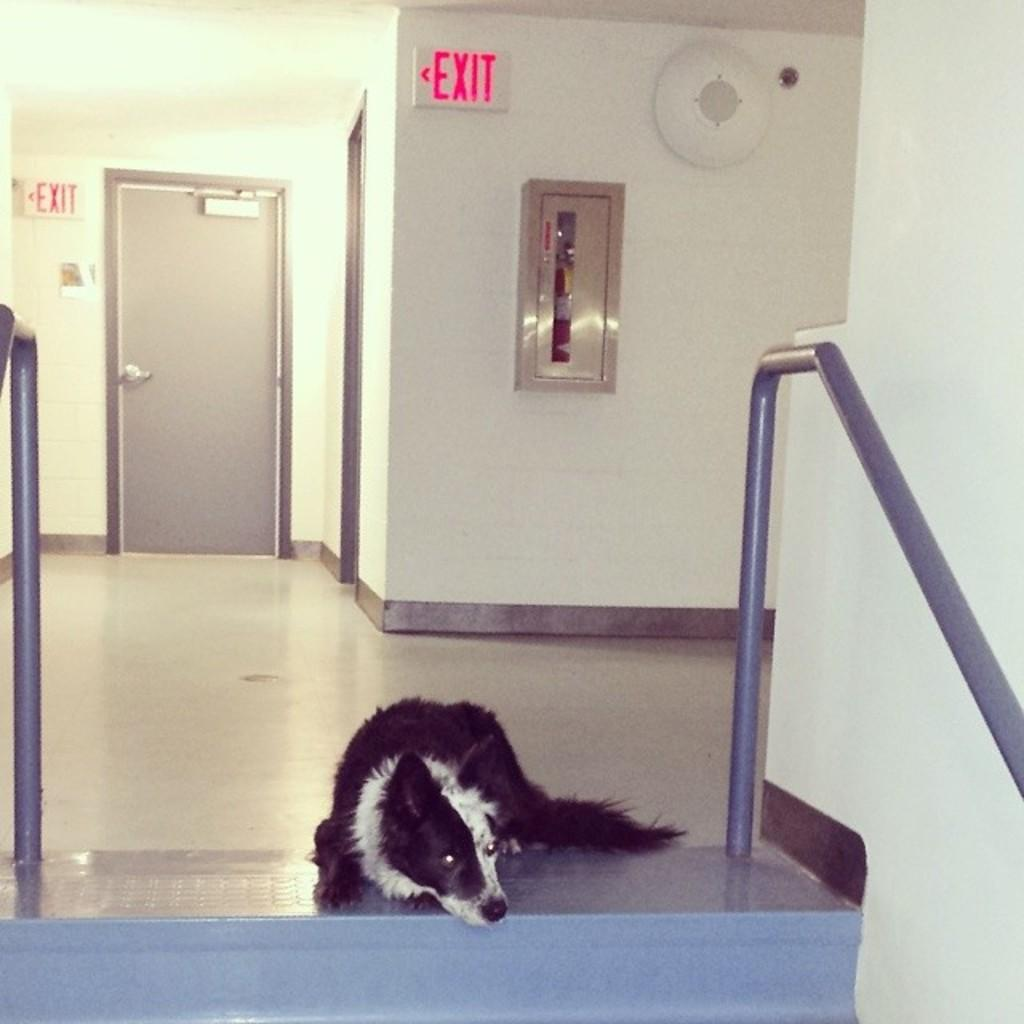What objects can be seen in the image that are long and straight? There are rods in the image. What type of structures are present in the image? There are walls in the image. What signs are visible in the image that indicate a way out? There are exit boards in the image. What feature in the image allows access to different areas? There is a door in the image. What animal can be seen resting on the floor in the image? A dog is sleeping on the floor in the image. What type of scarf is the friend wearing in the image? There is no friend or scarf present in the image. What effect does the dog's presence have on the walls in the image? The dog's presence does not have any effect on the walls in the image; they are separate entities. 